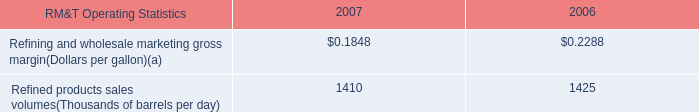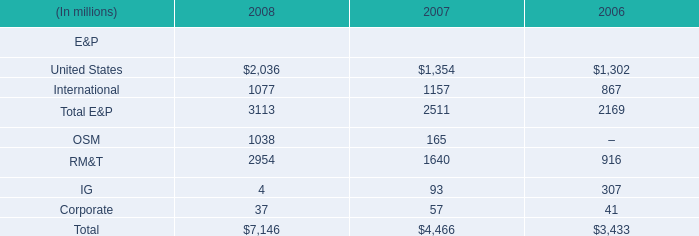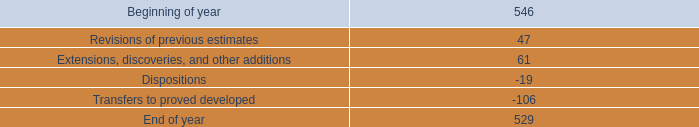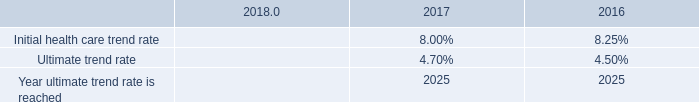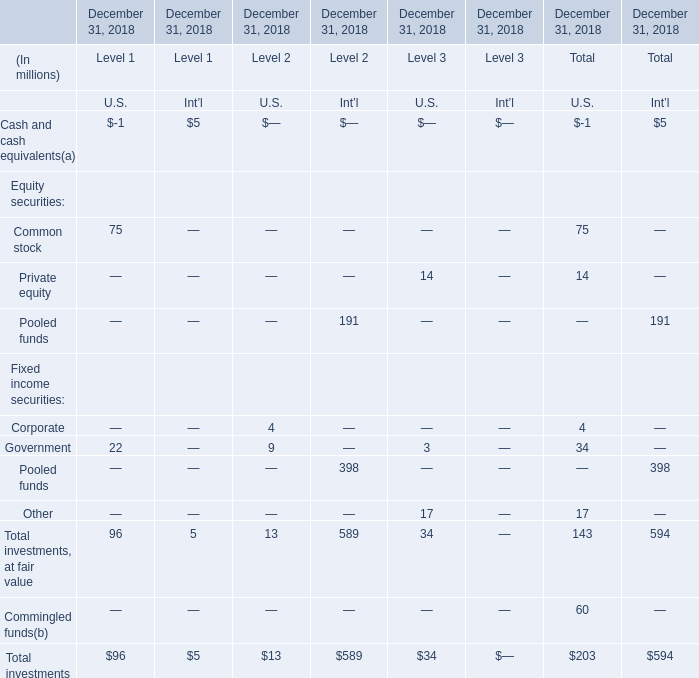what percentage decrease of proved undeveloped reserves occurred during 2018? 
Computations: (17 / 546)
Answer: 0.03114. 